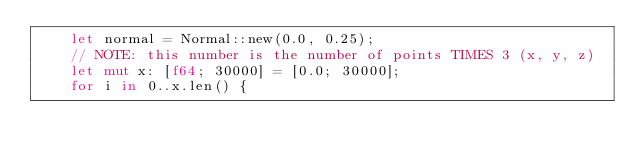<code> <loc_0><loc_0><loc_500><loc_500><_Rust_>    let normal = Normal::new(0.0, 0.25);
    // NOTE: this number is the number of points TIMES 3 (x, y, z)
    let mut x: [f64; 30000] = [0.0; 30000];
    for i in 0..x.len() {</code> 